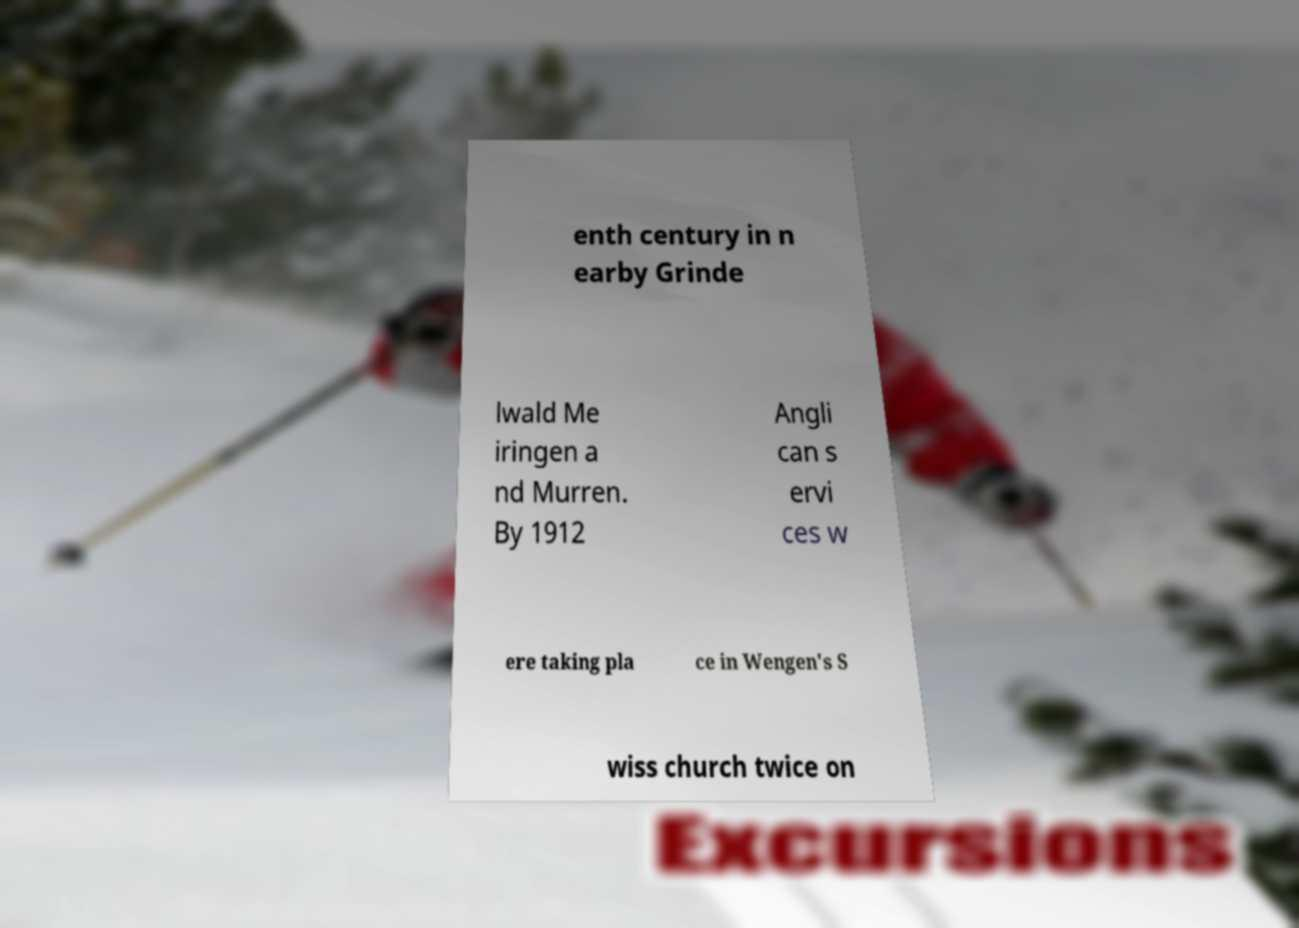For documentation purposes, I need the text within this image transcribed. Could you provide that? enth century in n earby Grinde lwald Me iringen a nd Murren. By 1912 Angli can s ervi ces w ere taking pla ce in Wengen's S wiss church twice on 